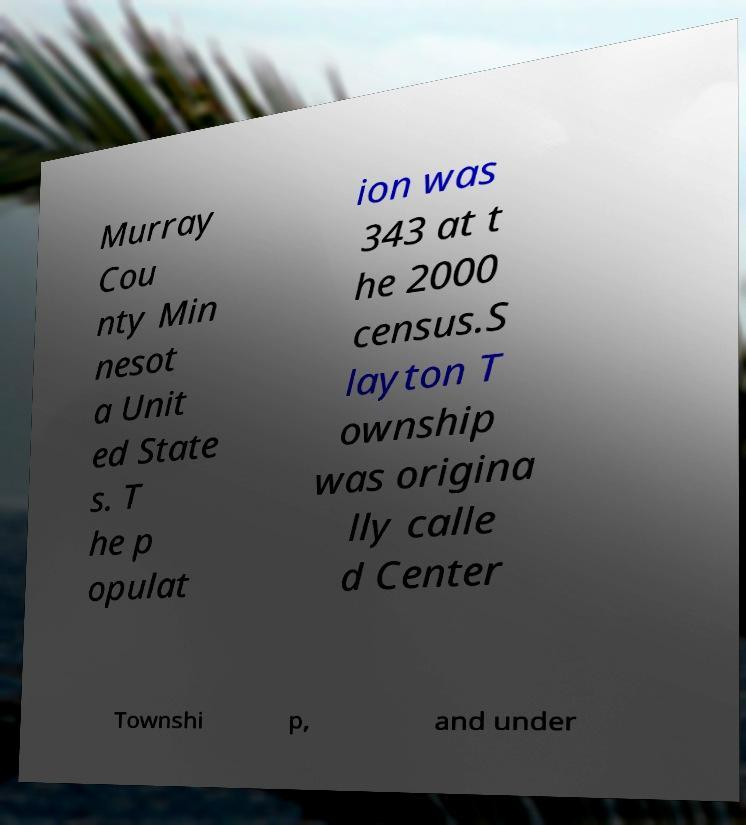Please read and relay the text visible in this image. What does it say? Murray Cou nty Min nesot a Unit ed State s. T he p opulat ion was 343 at t he 2000 census.S layton T ownship was origina lly calle d Center Townshi p, and under 